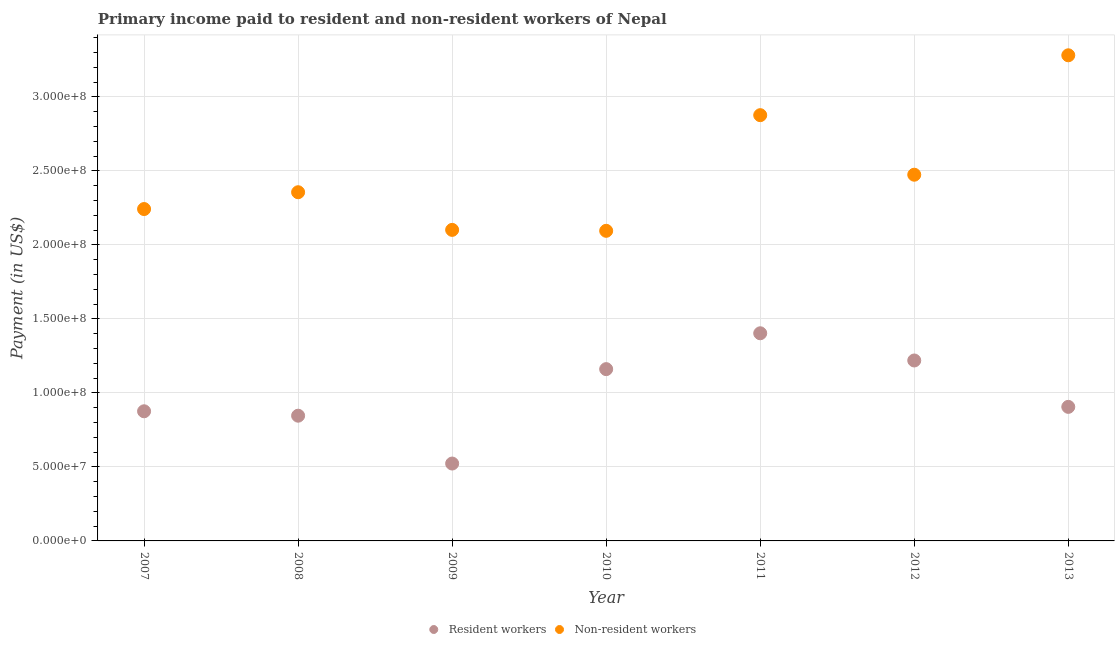How many different coloured dotlines are there?
Ensure brevity in your answer.  2. Is the number of dotlines equal to the number of legend labels?
Keep it short and to the point. Yes. What is the payment made to resident workers in 2011?
Your response must be concise. 1.40e+08. Across all years, what is the maximum payment made to resident workers?
Provide a succinct answer. 1.40e+08. Across all years, what is the minimum payment made to non-resident workers?
Your response must be concise. 2.10e+08. In which year was the payment made to resident workers maximum?
Your answer should be very brief. 2011. In which year was the payment made to resident workers minimum?
Provide a succinct answer. 2009. What is the total payment made to resident workers in the graph?
Your answer should be very brief. 6.93e+08. What is the difference between the payment made to non-resident workers in 2007 and that in 2008?
Keep it short and to the point. -1.14e+07. What is the difference between the payment made to non-resident workers in 2007 and the payment made to resident workers in 2010?
Make the answer very short. 1.08e+08. What is the average payment made to resident workers per year?
Offer a very short reply. 9.91e+07. In the year 2011, what is the difference between the payment made to resident workers and payment made to non-resident workers?
Give a very brief answer. -1.47e+08. In how many years, is the payment made to non-resident workers greater than 180000000 US$?
Offer a very short reply. 7. What is the ratio of the payment made to resident workers in 2010 to that in 2011?
Offer a terse response. 0.83. Is the payment made to resident workers in 2008 less than that in 2011?
Provide a short and direct response. Yes. Is the difference between the payment made to resident workers in 2007 and 2010 greater than the difference between the payment made to non-resident workers in 2007 and 2010?
Ensure brevity in your answer.  No. What is the difference between the highest and the second highest payment made to resident workers?
Your response must be concise. 1.84e+07. What is the difference between the highest and the lowest payment made to non-resident workers?
Keep it short and to the point. 1.19e+08. In how many years, is the payment made to non-resident workers greater than the average payment made to non-resident workers taken over all years?
Give a very brief answer. 2. Does the payment made to non-resident workers monotonically increase over the years?
Offer a very short reply. No. Is the payment made to resident workers strictly greater than the payment made to non-resident workers over the years?
Your answer should be compact. No. How many years are there in the graph?
Provide a short and direct response. 7. What is the difference between two consecutive major ticks on the Y-axis?
Your answer should be very brief. 5.00e+07. Does the graph contain grids?
Your answer should be compact. Yes. How many legend labels are there?
Provide a succinct answer. 2. How are the legend labels stacked?
Provide a short and direct response. Horizontal. What is the title of the graph?
Your answer should be compact. Primary income paid to resident and non-resident workers of Nepal. Does "Non-solid fuel" appear as one of the legend labels in the graph?
Keep it short and to the point. No. What is the label or title of the Y-axis?
Make the answer very short. Payment (in US$). What is the Payment (in US$) in Resident workers in 2007?
Provide a short and direct response. 8.76e+07. What is the Payment (in US$) of Non-resident workers in 2007?
Offer a terse response. 2.24e+08. What is the Payment (in US$) of Resident workers in 2008?
Your answer should be very brief. 8.46e+07. What is the Payment (in US$) of Non-resident workers in 2008?
Give a very brief answer. 2.36e+08. What is the Payment (in US$) in Resident workers in 2009?
Ensure brevity in your answer.  5.23e+07. What is the Payment (in US$) of Non-resident workers in 2009?
Provide a succinct answer. 2.10e+08. What is the Payment (in US$) in Resident workers in 2010?
Make the answer very short. 1.16e+08. What is the Payment (in US$) of Non-resident workers in 2010?
Provide a short and direct response. 2.10e+08. What is the Payment (in US$) of Resident workers in 2011?
Provide a succinct answer. 1.40e+08. What is the Payment (in US$) in Non-resident workers in 2011?
Make the answer very short. 2.88e+08. What is the Payment (in US$) in Resident workers in 2012?
Provide a succinct answer. 1.22e+08. What is the Payment (in US$) of Non-resident workers in 2012?
Keep it short and to the point. 2.47e+08. What is the Payment (in US$) in Resident workers in 2013?
Your answer should be compact. 9.06e+07. What is the Payment (in US$) in Non-resident workers in 2013?
Your answer should be very brief. 3.28e+08. Across all years, what is the maximum Payment (in US$) of Resident workers?
Your response must be concise. 1.40e+08. Across all years, what is the maximum Payment (in US$) of Non-resident workers?
Your answer should be very brief. 3.28e+08. Across all years, what is the minimum Payment (in US$) of Resident workers?
Make the answer very short. 5.23e+07. Across all years, what is the minimum Payment (in US$) of Non-resident workers?
Provide a succinct answer. 2.10e+08. What is the total Payment (in US$) in Resident workers in the graph?
Offer a very short reply. 6.93e+08. What is the total Payment (in US$) of Non-resident workers in the graph?
Your answer should be compact. 1.74e+09. What is the difference between the Payment (in US$) of Resident workers in 2007 and that in 2008?
Your answer should be very brief. 2.98e+06. What is the difference between the Payment (in US$) of Non-resident workers in 2007 and that in 2008?
Your response must be concise. -1.14e+07. What is the difference between the Payment (in US$) in Resident workers in 2007 and that in 2009?
Your answer should be compact. 3.53e+07. What is the difference between the Payment (in US$) in Non-resident workers in 2007 and that in 2009?
Your answer should be compact. 1.41e+07. What is the difference between the Payment (in US$) of Resident workers in 2007 and that in 2010?
Offer a terse response. -2.85e+07. What is the difference between the Payment (in US$) in Non-resident workers in 2007 and that in 2010?
Offer a terse response. 1.47e+07. What is the difference between the Payment (in US$) of Resident workers in 2007 and that in 2011?
Keep it short and to the point. -5.27e+07. What is the difference between the Payment (in US$) of Non-resident workers in 2007 and that in 2011?
Offer a very short reply. -6.34e+07. What is the difference between the Payment (in US$) of Resident workers in 2007 and that in 2012?
Provide a short and direct response. -3.43e+07. What is the difference between the Payment (in US$) of Non-resident workers in 2007 and that in 2012?
Your answer should be compact. -2.32e+07. What is the difference between the Payment (in US$) in Resident workers in 2007 and that in 2013?
Provide a succinct answer. -2.98e+06. What is the difference between the Payment (in US$) of Non-resident workers in 2007 and that in 2013?
Your answer should be very brief. -1.04e+08. What is the difference between the Payment (in US$) of Resident workers in 2008 and that in 2009?
Offer a very short reply. 3.23e+07. What is the difference between the Payment (in US$) in Non-resident workers in 2008 and that in 2009?
Offer a very short reply. 2.54e+07. What is the difference between the Payment (in US$) of Resident workers in 2008 and that in 2010?
Your answer should be compact. -3.15e+07. What is the difference between the Payment (in US$) of Non-resident workers in 2008 and that in 2010?
Your response must be concise. 2.61e+07. What is the difference between the Payment (in US$) in Resident workers in 2008 and that in 2011?
Your answer should be very brief. -5.57e+07. What is the difference between the Payment (in US$) of Non-resident workers in 2008 and that in 2011?
Your answer should be very brief. -5.21e+07. What is the difference between the Payment (in US$) in Resident workers in 2008 and that in 2012?
Give a very brief answer. -3.73e+07. What is the difference between the Payment (in US$) of Non-resident workers in 2008 and that in 2012?
Give a very brief answer. -1.18e+07. What is the difference between the Payment (in US$) of Resident workers in 2008 and that in 2013?
Provide a succinct answer. -5.96e+06. What is the difference between the Payment (in US$) of Non-resident workers in 2008 and that in 2013?
Provide a short and direct response. -9.25e+07. What is the difference between the Payment (in US$) of Resident workers in 2009 and that in 2010?
Your answer should be compact. -6.38e+07. What is the difference between the Payment (in US$) in Non-resident workers in 2009 and that in 2010?
Offer a terse response. 6.35e+05. What is the difference between the Payment (in US$) of Resident workers in 2009 and that in 2011?
Keep it short and to the point. -8.80e+07. What is the difference between the Payment (in US$) in Non-resident workers in 2009 and that in 2011?
Your answer should be compact. -7.75e+07. What is the difference between the Payment (in US$) of Resident workers in 2009 and that in 2012?
Your response must be concise. -6.96e+07. What is the difference between the Payment (in US$) in Non-resident workers in 2009 and that in 2012?
Make the answer very short. -3.73e+07. What is the difference between the Payment (in US$) in Resident workers in 2009 and that in 2013?
Your response must be concise. -3.83e+07. What is the difference between the Payment (in US$) of Non-resident workers in 2009 and that in 2013?
Provide a succinct answer. -1.18e+08. What is the difference between the Payment (in US$) in Resident workers in 2010 and that in 2011?
Your answer should be compact. -2.42e+07. What is the difference between the Payment (in US$) of Non-resident workers in 2010 and that in 2011?
Ensure brevity in your answer.  -7.82e+07. What is the difference between the Payment (in US$) of Resident workers in 2010 and that in 2012?
Your answer should be very brief. -5.85e+06. What is the difference between the Payment (in US$) in Non-resident workers in 2010 and that in 2012?
Give a very brief answer. -3.79e+07. What is the difference between the Payment (in US$) in Resident workers in 2010 and that in 2013?
Offer a very short reply. 2.55e+07. What is the difference between the Payment (in US$) in Non-resident workers in 2010 and that in 2013?
Keep it short and to the point. -1.19e+08. What is the difference between the Payment (in US$) of Resident workers in 2011 and that in 2012?
Ensure brevity in your answer.  1.84e+07. What is the difference between the Payment (in US$) of Non-resident workers in 2011 and that in 2012?
Provide a short and direct response. 4.02e+07. What is the difference between the Payment (in US$) in Resident workers in 2011 and that in 2013?
Your answer should be compact. 4.97e+07. What is the difference between the Payment (in US$) of Non-resident workers in 2011 and that in 2013?
Your response must be concise. -4.05e+07. What is the difference between the Payment (in US$) of Resident workers in 2012 and that in 2013?
Ensure brevity in your answer.  3.13e+07. What is the difference between the Payment (in US$) of Non-resident workers in 2012 and that in 2013?
Give a very brief answer. -8.07e+07. What is the difference between the Payment (in US$) of Resident workers in 2007 and the Payment (in US$) of Non-resident workers in 2008?
Ensure brevity in your answer.  -1.48e+08. What is the difference between the Payment (in US$) in Resident workers in 2007 and the Payment (in US$) in Non-resident workers in 2009?
Keep it short and to the point. -1.23e+08. What is the difference between the Payment (in US$) in Resident workers in 2007 and the Payment (in US$) in Non-resident workers in 2010?
Provide a succinct answer. -1.22e+08. What is the difference between the Payment (in US$) of Resident workers in 2007 and the Payment (in US$) of Non-resident workers in 2011?
Provide a short and direct response. -2.00e+08. What is the difference between the Payment (in US$) in Resident workers in 2007 and the Payment (in US$) in Non-resident workers in 2012?
Offer a very short reply. -1.60e+08. What is the difference between the Payment (in US$) in Resident workers in 2007 and the Payment (in US$) in Non-resident workers in 2013?
Your answer should be very brief. -2.41e+08. What is the difference between the Payment (in US$) of Resident workers in 2008 and the Payment (in US$) of Non-resident workers in 2009?
Offer a terse response. -1.26e+08. What is the difference between the Payment (in US$) of Resident workers in 2008 and the Payment (in US$) of Non-resident workers in 2010?
Make the answer very short. -1.25e+08. What is the difference between the Payment (in US$) in Resident workers in 2008 and the Payment (in US$) in Non-resident workers in 2011?
Your response must be concise. -2.03e+08. What is the difference between the Payment (in US$) of Resident workers in 2008 and the Payment (in US$) of Non-resident workers in 2012?
Provide a short and direct response. -1.63e+08. What is the difference between the Payment (in US$) in Resident workers in 2008 and the Payment (in US$) in Non-resident workers in 2013?
Ensure brevity in your answer.  -2.44e+08. What is the difference between the Payment (in US$) of Resident workers in 2009 and the Payment (in US$) of Non-resident workers in 2010?
Your answer should be very brief. -1.57e+08. What is the difference between the Payment (in US$) in Resident workers in 2009 and the Payment (in US$) in Non-resident workers in 2011?
Offer a terse response. -2.35e+08. What is the difference between the Payment (in US$) of Resident workers in 2009 and the Payment (in US$) of Non-resident workers in 2012?
Offer a very short reply. -1.95e+08. What is the difference between the Payment (in US$) in Resident workers in 2009 and the Payment (in US$) in Non-resident workers in 2013?
Your response must be concise. -2.76e+08. What is the difference between the Payment (in US$) of Resident workers in 2010 and the Payment (in US$) of Non-resident workers in 2011?
Provide a succinct answer. -1.72e+08. What is the difference between the Payment (in US$) in Resident workers in 2010 and the Payment (in US$) in Non-resident workers in 2012?
Offer a terse response. -1.31e+08. What is the difference between the Payment (in US$) in Resident workers in 2010 and the Payment (in US$) in Non-resident workers in 2013?
Give a very brief answer. -2.12e+08. What is the difference between the Payment (in US$) in Resident workers in 2011 and the Payment (in US$) in Non-resident workers in 2012?
Your answer should be very brief. -1.07e+08. What is the difference between the Payment (in US$) of Resident workers in 2011 and the Payment (in US$) of Non-resident workers in 2013?
Your answer should be compact. -1.88e+08. What is the difference between the Payment (in US$) of Resident workers in 2012 and the Payment (in US$) of Non-resident workers in 2013?
Your response must be concise. -2.06e+08. What is the average Payment (in US$) in Resident workers per year?
Offer a terse response. 9.91e+07. What is the average Payment (in US$) in Non-resident workers per year?
Your answer should be compact. 2.49e+08. In the year 2007, what is the difference between the Payment (in US$) of Resident workers and Payment (in US$) of Non-resident workers?
Your response must be concise. -1.37e+08. In the year 2008, what is the difference between the Payment (in US$) in Resident workers and Payment (in US$) in Non-resident workers?
Ensure brevity in your answer.  -1.51e+08. In the year 2009, what is the difference between the Payment (in US$) in Resident workers and Payment (in US$) in Non-resident workers?
Offer a very short reply. -1.58e+08. In the year 2010, what is the difference between the Payment (in US$) of Resident workers and Payment (in US$) of Non-resident workers?
Your answer should be compact. -9.35e+07. In the year 2011, what is the difference between the Payment (in US$) in Resident workers and Payment (in US$) in Non-resident workers?
Keep it short and to the point. -1.47e+08. In the year 2012, what is the difference between the Payment (in US$) of Resident workers and Payment (in US$) of Non-resident workers?
Give a very brief answer. -1.26e+08. In the year 2013, what is the difference between the Payment (in US$) in Resident workers and Payment (in US$) in Non-resident workers?
Your answer should be compact. -2.38e+08. What is the ratio of the Payment (in US$) of Resident workers in 2007 to that in 2008?
Your response must be concise. 1.04. What is the ratio of the Payment (in US$) in Non-resident workers in 2007 to that in 2008?
Ensure brevity in your answer.  0.95. What is the ratio of the Payment (in US$) of Resident workers in 2007 to that in 2009?
Your answer should be very brief. 1.68. What is the ratio of the Payment (in US$) in Non-resident workers in 2007 to that in 2009?
Provide a short and direct response. 1.07. What is the ratio of the Payment (in US$) of Resident workers in 2007 to that in 2010?
Make the answer very short. 0.75. What is the ratio of the Payment (in US$) of Non-resident workers in 2007 to that in 2010?
Your answer should be very brief. 1.07. What is the ratio of the Payment (in US$) in Resident workers in 2007 to that in 2011?
Keep it short and to the point. 0.62. What is the ratio of the Payment (in US$) in Non-resident workers in 2007 to that in 2011?
Your answer should be very brief. 0.78. What is the ratio of the Payment (in US$) of Resident workers in 2007 to that in 2012?
Offer a terse response. 0.72. What is the ratio of the Payment (in US$) of Non-resident workers in 2007 to that in 2012?
Keep it short and to the point. 0.91. What is the ratio of the Payment (in US$) in Resident workers in 2007 to that in 2013?
Ensure brevity in your answer.  0.97. What is the ratio of the Payment (in US$) of Non-resident workers in 2007 to that in 2013?
Your answer should be compact. 0.68. What is the ratio of the Payment (in US$) of Resident workers in 2008 to that in 2009?
Ensure brevity in your answer.  1.62. What is the ratio of the Payment (in US$) of Non-resident workers in 2008 to that in 2009?
Ensure brevity in your answer.  1.12. What is the ratio of the Payment (in US$) of Resident workers in 2008 to that in 2010?
Your answer should be very brief. 0.73. What is the ratio of the Payment (in US$) of Non-resident workers in 2008 to that in 2010?
Your answer should be very brief. 1.12. What is the ratio of the Payment (in US$) in Resident workers in 2008 to that in 2011?
Make the answer very short. 0.6. What is the ratio of the Payment (in US$) of Non-resident workers in 2008 to that in 2011?
Your answer should be very brief. 0.82. What is the ratio of the Payment (in US$) in Resident workers in 2008 to that in 2012?
Keep it short and to the point. 0.69. What is the ratio of the Payment (in US$) of Non-resident workers in 2008 to that in 2012?
Your response must be concise. 0.95. What is the ratio of the Payment (in US$) in Resident workers in 2008 to that in 2013?
Give a very brief answer. 0.93. What is the ratio of the Payment (in US$) of Non-resident workers in 2008 to that in 2013?
Offer a very short reply. 0.72. What is the ratio of the Payment (in US$) in Resident workers in 2009 to that in 2010?
Offer a very short reply. 0.45. What is the ratio of the Payment (in US$) of Non-resident workers in 2009 to that in 2010?
Your answer should be very brief. 1. What is the ratio of the Payment (in US$) of Resident workers in 2009 to that in 2011?
Provide a short and direct response. 0.37. What is the ratio of the Payment (in US$) in Non-resident workers in 2009 to that in 2011?
Give a very brief answer. 0.73. What is the ratio of the Payment (in US$) in Resident workers in 2009 to that in 2012?
Your answer should be very brief. 0.43. What is the ratio of the Payment (in US$) in Non-resident workers in 2009 to that in 2012?
Your answer should be compact. 0.85. What is the ratio of the Payment (in US$) in Resident workers in 2009 to that in 2013?
Provide a succinct answer. 0.58. What is the ratio of the Payment (in US$) of Non-resident workers in 2009 to that in 2013?
Your answer should be very brief. 0.64. What is the ratio of the Payment (in US$) of Resident workers in 2010 to that in 2011?
Keep it short and to the point. 0.83. What is the ratio of the Payment (in US$) in Non-resident workers in 2010 to that in 2011?
Give a very brief answer. 0.73. What is the ratio of the Payment (in US$) in Non-resident workers in 2010 to that in 2012?
Keep it short and to the point. 0.85. What is the ratio of the Payment (in US$) of Resident workers in 2010 to that in 2013?
Offer a terse response. 1.28. What is the ratio of the Payment (in US$) in Non-resident workers in 2010 to that in 2013?
Your answer should be compact. 0.64. What is the ratio of the Payment (in US$) of Resident workers in 2011 to that in 2012?
Offer a very short reply. 1.15. What is the ratio of the Payment (in US$) in Non-resident workers in 2011 to that in 2012?
Your answer should be compact. 1.16. What is the ratio of the Payment (in US$) in Resident workers in 2011 to that in 2013?
Offer a very short reply. 1.55. What is the ratio of the Payment (in US$) in Non-resident workers in 2011 to that in 2013?
Provide a short and direct response. 0.88. What is the ratio of the Payment (in US$) in Resident workers in 2012 to that in 2013?
Your response must be concise. 1.35. What is the ratio of the Payment (in US$) of Non-resident workers in 2012 to that in 2013?
Your response must be concise. 0.75. What is the difference between the highest and the second highest Payment (in US$) in Resident workers?
Keep it short and to the point. 1.84e+07. What is the difference between the highest and the second highest Payment (in US$) in Non-resident workers?
Your answer should be very brief. 4.05e+07. What is the difference between the highest and the lowest Payment (in US$) in Resident workers?
Offer a very short reply. 8.80e+07. What is the difference between the highest and the lowest Payment (in US$) in Non-resident workers?
Your answer should be compact. 1.19e+08. 